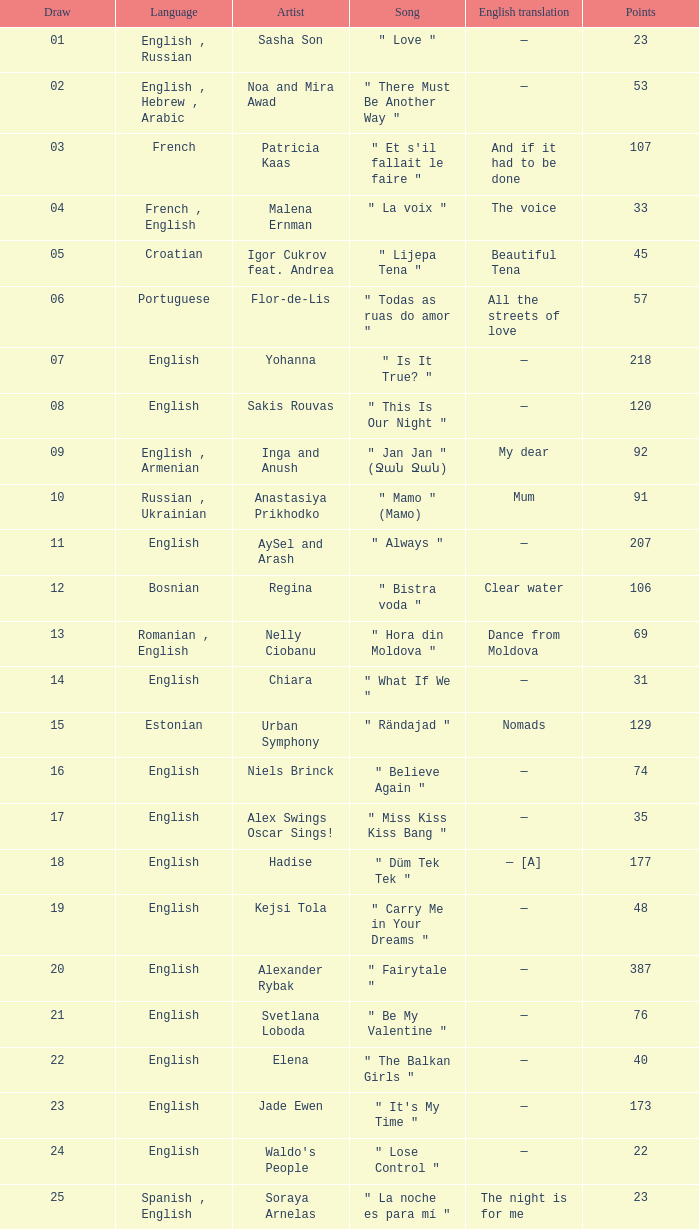Would you mind parsing the complete table? {'header': ['Draw', 'Language', 'Artist', 'Song', 'English translation', 'Points'], 'rows': [['01', 'English , Russian', 'Sasha Son', '" Love "', '—', '23'], ['02', 'English , Hebrew , Arabic', 'Noa and Mira Awad', '" There Must Be Another Way "', '—', '53'], ['03', 'French', 'Patricia Kaas', '" Et s\'il fallait le faire "', 'And if it had to be done', '107'], ['04', 'French , English', 'Malena Ernman', '" La voix "', 'The voice', '33'], ['05', 'Croatian', 'Igor Cukrov feat. Andrea', '" Lijepa Tena "', 'Beautiful Tena', '45'], ['06', 'Portuguese', 'Flor-de-Lis', '" Todas as ruas do amor "', 'All the streets of love', '57'], ['07', 'English', 'Yohanna', '" Is It True? "', '—', '218'], ['08', 'English', 'Sakis Rouvas', '" This Is Our Night "', '—', '120'], ['09', 'English , Armenian', 'Inga and Anush', '" Jan Jan " (Ջան Ջան)', 'My dear', '92'], ['10', 'Russian , Ukrainian', 'Anastasiya Prikhodko', '" Mamo " (Мамо)', 'Mum', '91'], ['11', 'English', 'AySel and Arash', '" Always "', '—', '207'], ['12', 'Bosnian', 'Regina', '" Bistra voda "', 'Clear water', '106'], ['13', 'Romanian , English', 'Nelly Ciobanu', '" Hora din Moldova "', 'Dance from Moldova', '69'], ['14', 'English', 'Chiara', '" What If We "', '—', '31'], ['15', 'Estonian', 'Urban Symphony', '" Rändajad "', 'Nomads', '129'], ['16', 'English', 'Niels Brinck', '" Believe Again "', '—', '74'], ['17', 'English', 'Alex Swings Oscar Sings!', '" Miss Kiss Kiss Bang "', '—', '35'], ['18', 'English', 'Hadise', '" Düm Tek Tek "', '— [A]', '177'], ['19', 'English', 'Kejsi Tola', '" Carry Me in Your Dreams "', '—', '48'], ['20', 'English', 'Alexander Rybak', '" Fairytale "', '—', '387'], ['21', 'English', 'Svetlana Loboda', '" Be My Valentine "', '—', '76'], ['22', 'English', 'Elena', '" The Balkan Girls "', '—', '40'], ['23', 'English', 'Jade Ewen', '" It\'s My Time "', '—', '173'], ['24', 'English', "Waldo's People", '" Lose Control "', '—', '22'], ['25', 'Spanish , English', 'Soraya Arnelas', '" La noche es para mí "', 'The night is for me', '23']]} What song was in french? " Et s'il fallait le faire ". 